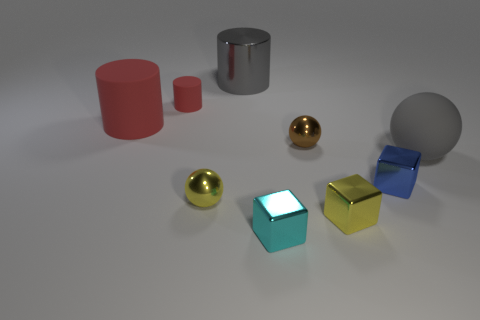Are there any shadows visible in the scene, and if so, what do they reveal about the lighting? Shadows are indeed present beneath every object, and they are somewhat soft-edged, indicating that the light source, likely positioned above, is not extremely close to the objects. The shadows help to give a sense of the spatial arrangement and relative height of the objects on the surface. 